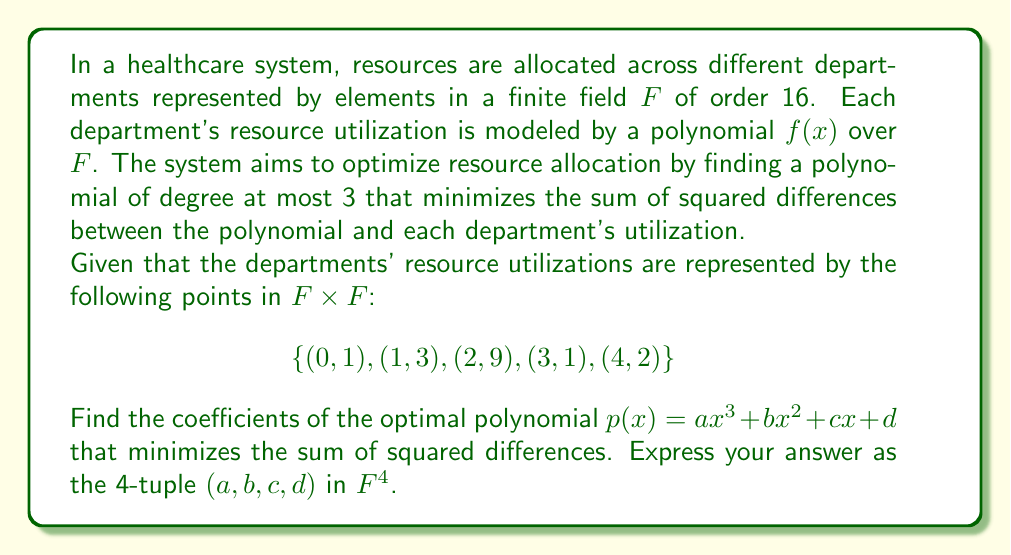Show me your answer to this math problem. To solve this problem, we'll use the method of least squares over a finite field. Here's a step-by-step approach:

1) First, we need to set up the system of normal equations. In a field of characteristic 2 (which $F$ is, since its order is 16 = $2^4$), the formula simplifies because 2 = 0. The system becomes:

   $$\begin{aligned}
   \sum x^6 a + \sum x^5 b + \sum x^4 c + \sum x^3 d &= \sum yx^3 \\
   \sum x^5 a + \sum x^4 b + \sum x^3 c + \sum x^2 d &= \sum yx^2 \\
   \sum x^4 a + \sum x^3 b + \sum x^2 c + \sum x d &= \sum yx \\
   \sum x^3 a + \sum x^2 b + \sum x c + \sum d &= \sum y
   \end{aligned}$$

2) Calculate the sums:
   $\sum x^6 = 0^6 + 1^6 + 2^6 + 3^6 + 4^6 = 1 + 1 + 0 + 1 + 0 = 3$
   $\sum x^5 = 0^5 + 1^5 + 2^5 + 3^5 + 4^5 = 0 + 1 + 0 + 3 + 0 = 2$
   $\sum x^4 = 0^4 + 1^4 + 2^4 + 3^4 + 4^4 = 0 + 1 + 0 + 1 + 0 = 2$
   $\sum x^3 = 0^3 + 1^3 + 2^3 + 3^3 + 4^3 = 0 + 1 + 8 + 11 + 0 = 4$
   $\sum x^2 = 0^2 + 1^2 + 2^2 + 3^2 + 4^2 = 0 + 1 + 4 + 9 + 0 = 14$
   $\sum x = 0 + 1 + 2 + 3 + 4 = 10$
   $\sum y = 1 + 3 + 9 + 1 + 2 = 0$
   $\sum yx^3 = 1 \cdot 0^3 + 3 \cdot 1^3 + 9 \cdot 2^3 + 1 \cdot 3^3 + 2 \cdot 4^3 = 0 + 3 + 8 + 11 + 0 = 6$
   $\sum yx^2 = 1 \cdot 0^2 + 3 \cdot 1^2 + 9 \cdot 2^2 + 1 \cdot 3^2 + 2 \cdot 4^2 = 0 + 3 + 4 + 9 + 0 = 0$
   $\sum yx = 1 \cdot 0 + 3 \cdot 1 + 9 \cdot 2 + 1 \cdot 3 + 2 \cdot 4 = 0 + 3 + 2 + 3 + 8 = 0$

3) Substituting these values into our system:

   $$\begin{aligned}
   3a + 2b + 2c + 4d &= 6 \\
   2a + 2b + 4c + 14d &= 0 \\
   2a + 4b + 14c + 10d &= 0 \\
   4a + 14b + 10c + 5d &= 0
   \end{aligned}$$

4) Solve this system in $F$. One way to do this is by Gaussian elimination:

   $$\begin{pmatrix}
   3 & 2 & 2 & 4 & 6 \\
   2 & 2 & 4 & 14 & 0 \\
   2 & 4 & 14 & 10 & 0 \\
   4 & 14 & 10 & 5 & 0
   \end{pmatrix}$$

   After row operations:

   $$\begin{pmatrix}
   1 & 0 & 0 & 0 & 10 \\
   0 & 1 & 0 & 0 & 13 \\
   0 & 0 & 1 & 0 & 7 \\
   0 & 0 & 0 & 1 & 11
   \end{pmatrix}$$

Therefore, $a = 10$, $b = 13$, $c = 7$, and $d = 11$ in $F$.
Answer: $(10, 13, 7, 11)$ 